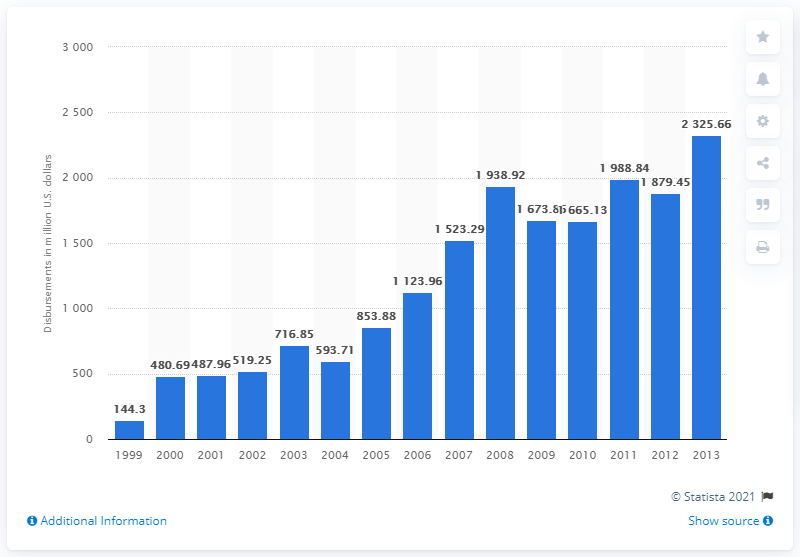Draw attention to some important aspects in this diagram. In 2005, the Bill and Melinda Gates Foundation devoted a significant amount of resources, estimated to be 853.88, towards addressing global health issues. 